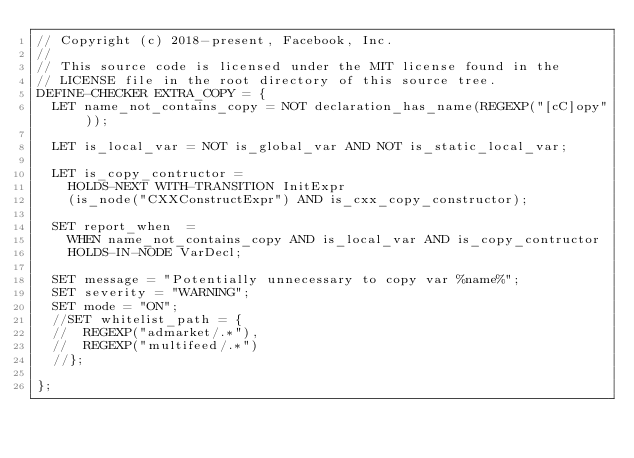Convert code to text. <code><loc_0><loc_0><loc_500><loc_500><_Perl_>// Copyright (c) 2018-present, Facebook, Inc.
//
// This source code is licensed under the MIT license found in the
// LICENSE file in the root directory of this source tree.
DEFINE-CHECKER EXTRA_COPY = {
  LET name_not_contains_copy = NOT declaration_has_name(REGEXP("[cC]opy"));

  LET is_local_var = NOT is_global_var AND NOT is_static_local_var;

  LET is_copy_contructor =
    HOLDS-NEXT WITH-TRANSITION InitExpr
    (is_node("CXXConstructExpr") AND is_cxx_copy_constructor);

  SET report_when  =
    WHEN name_not_contains_copy AND is_local_var AND is_copy_contructor
    HOLDS-IN-NODE VarDecl;

  SET message = "Potentially unnecessary to copy var %name%";
  SET severity = "WARNING";
  SET mode = "ON";
  //SET whitelist_path = {
  //  REGEXP("admarket/.*"),
  //  REGEXP("multifeed/.*")
  //};

};
</code> 